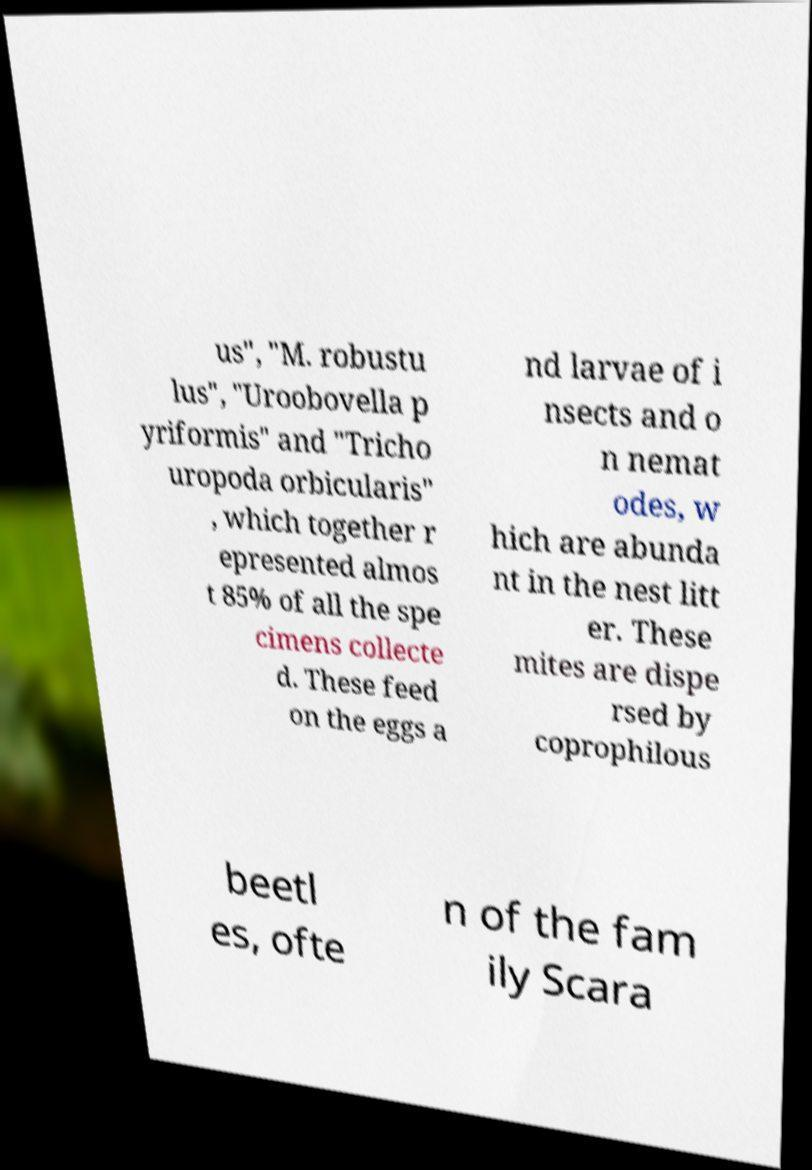Can you read and provide the text displayed in the image?This photo seems to have some interesting text. Can you extract and type it out for me? us", "M. robustu lus", "Uroobovella p yriformis" and "Tricho uropoda orbicularis" , which together r epresented almos t 85% of all the spe cimens collecte d. These feed on the eggs a nd larvae of i nsects and o n nemat odes, w hich are abunda nt in the nest litt er. These mites are dispe rsed by coprophilous beetl es, ofte n of the fam ily Scara 